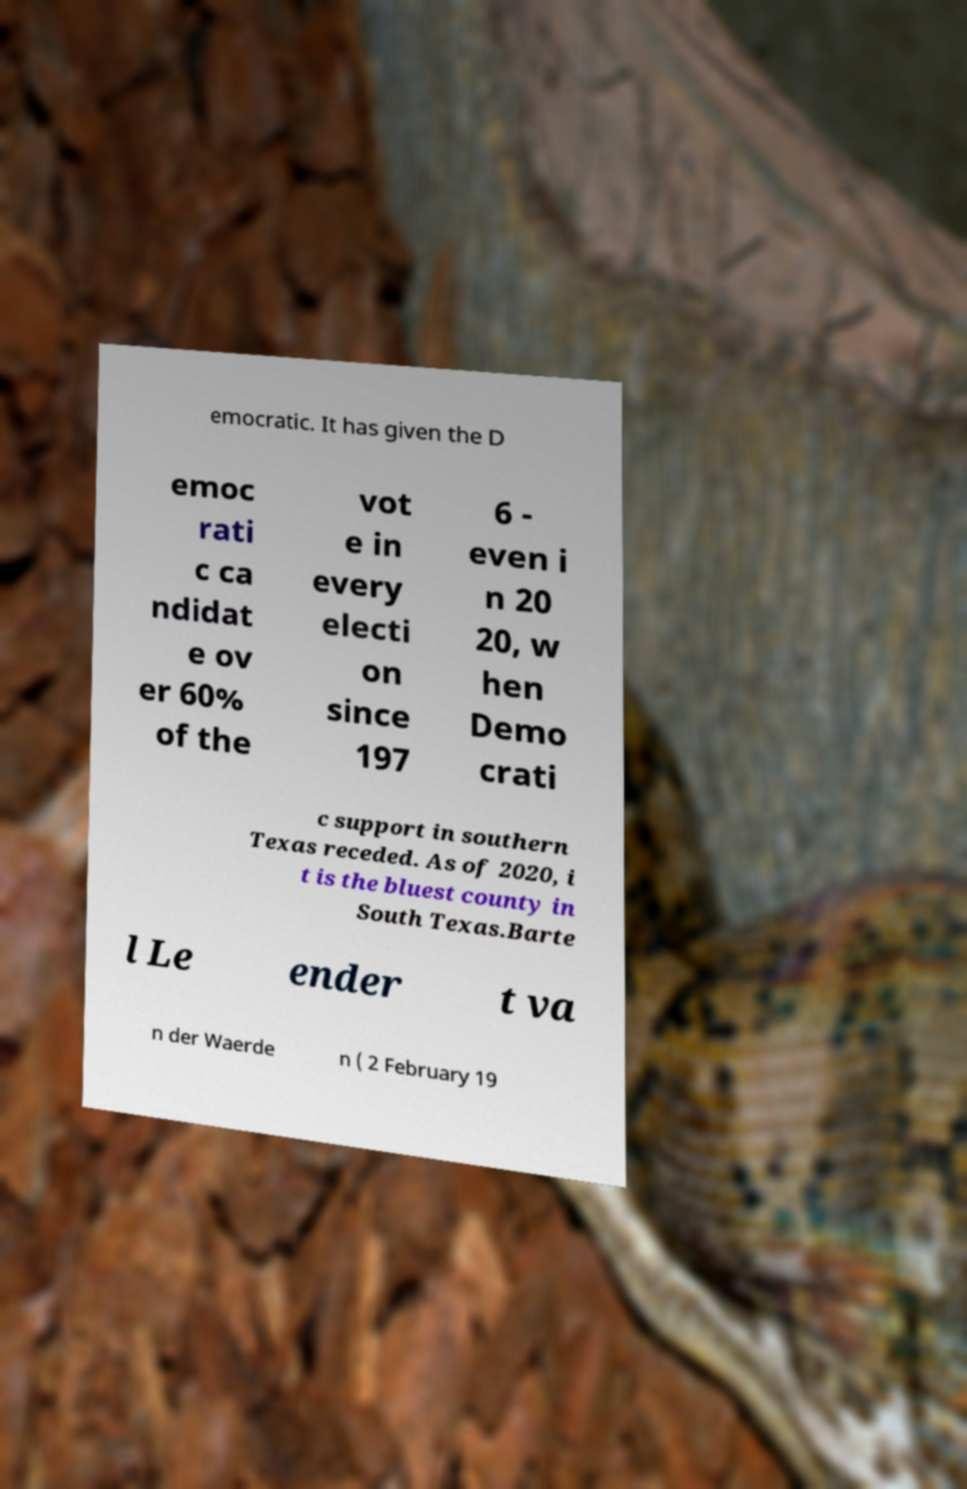Can you accurately transcribe the text from the provided image for me? emocratic. It has given the D emoc rati c ca ndidat e ov er 60% of the vot e in every electi on since 197 6 - even i n 20 20, w hen Demo crati c support in southern Texas receded. As of 2020, i t is the bluest county in South Texas.Barte l Le ender t va n der Waerde n ( 2 February 19 